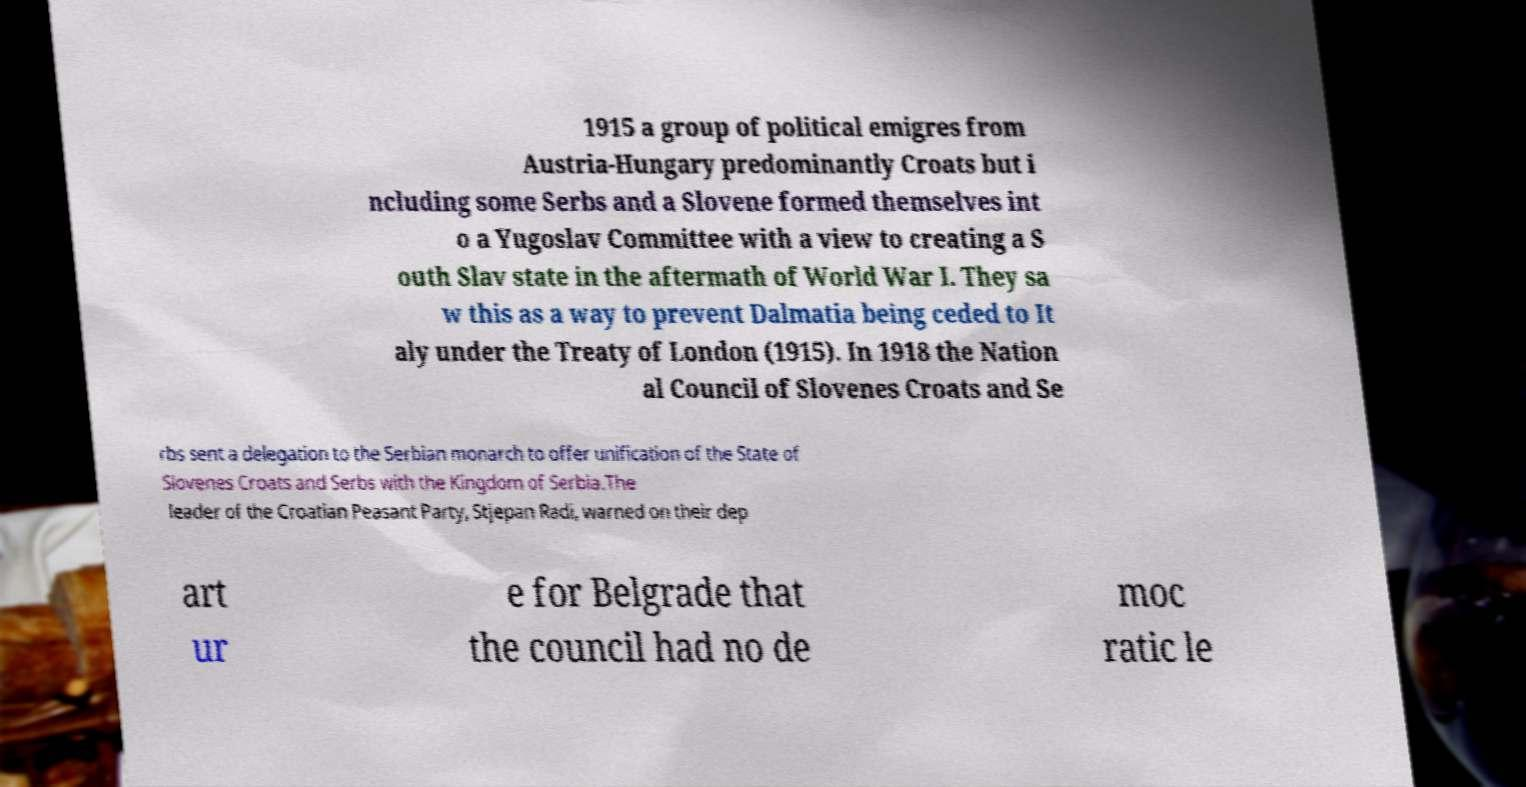For documentation purposes, I need the text within this image transcribed. Could you provide that? 1915 a group of political emigres from Austria-Hungary predominantly Croats but i ncluding some Serbs and a Slovene formed themselves int o a Yugoslav Committee with a view to creating a S outh Slav state in the aftermath of World War I. They sa w this as a way to prevent Dalmatia being ceded to It aly under the Treaty of London (1915). In 1918 the Nation al Council of Slovenes Croats and Se rbs sent a delegation to the Serbian monarch to offer unification of the State of Slovenes Croats and Serbs with the Kingdom of Serbia.The leader of the Croatian Peasant Party, Stjepan Radi, warned on their dep art ur e for Belgrade that the council had no de moc ratic le 